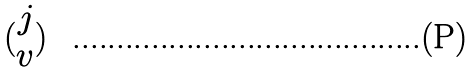Convert formula to latex. <formula><loc_0><loc_0><loc_500><loc_500>( \begin{matrix} j \\ v \end{matrix} )</formula> 